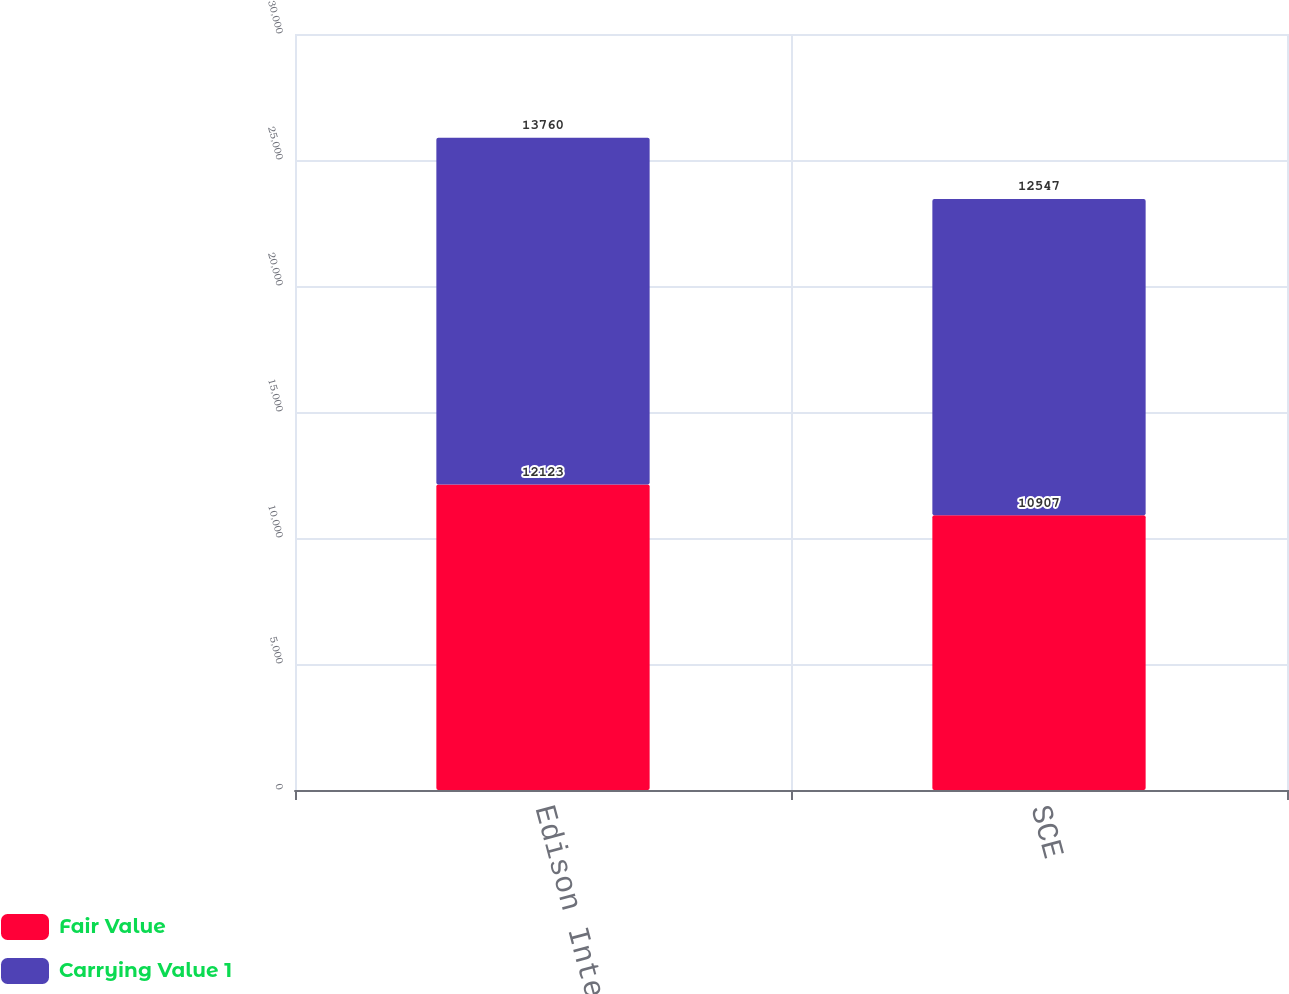Convert chart to OTSL. <chart><loc_0><loc_0><loc_500><loc_500><stacked_bar_chart><ecel><fcel>Edison International<fcel>SCE<nl><fcel>Fair Value<fcel>12123<fcel>10907<nl><fcel>Carrying Value 1<fcel>13760<fcel>12547<nl></chart> 